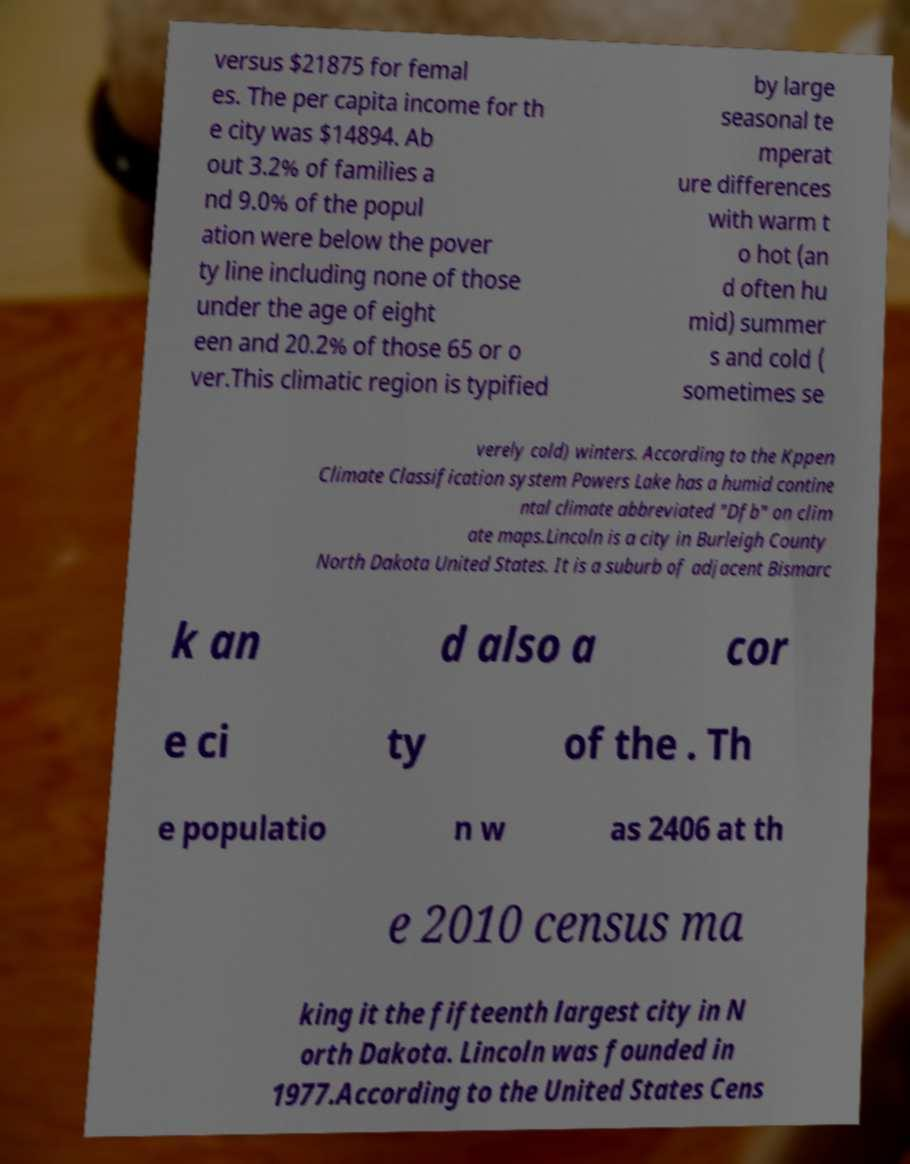For documentation purposes, I need the text within this image transcribed. Could you provide that? versus $21875 for femal es. The per capita income for th e city was $14894. Ab out 3.2% of families a nd 9.0% of the popul ation were below the pover ty line including none of those under the age of eight een and 20.2% of those 65 or o ver.This climatic region is typified by large seasonal te mperat ure differences with warm t o hot (an d often hu mid) summer s and cold ( sometimes se verely cold) winters. According to the Kppen Climate Classification system Powers Lake has a humid contine ntal climate abbreviated "Dfb" on clim ate maps.Lincoln is a city in Burleigh County North Dakota United States. It is a suburb of adjacent Bismarc k an d also a cor e ci ty of the . Th e populatio n w as 2406 at th e 2010 census ma king it the fifteenth largest city in N orth Dakota. Lincoln was founded in 1977.According to the United States Cens 